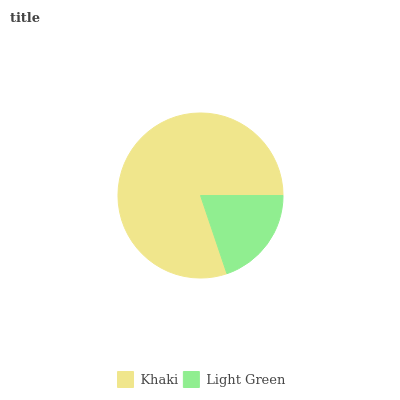Is Light Green the minimum?
Answer yes or no. Yes. Is Khaki the maximum?
Answer yes or no. Yes. Is Light Green the maximum?
Answer yes or no. No. Is Khaki greater than Light Green?
Answer yes or no. Yes. Is Light Green less than Khaki?
Answer yes or no. Yes. Is Light Green greater than Khaki?
Answer yes or no. No. Is Khaki less than Light Green?
Answer yes or no. No. Is Khaki the high median?
Answer yes or no. Yes. Is Light Green the low median?
Answer yes or no. Yes. Is Light Green the high median?
Answer yes or no. No. Is Khaki the low median?
Answer yes or no. No. 